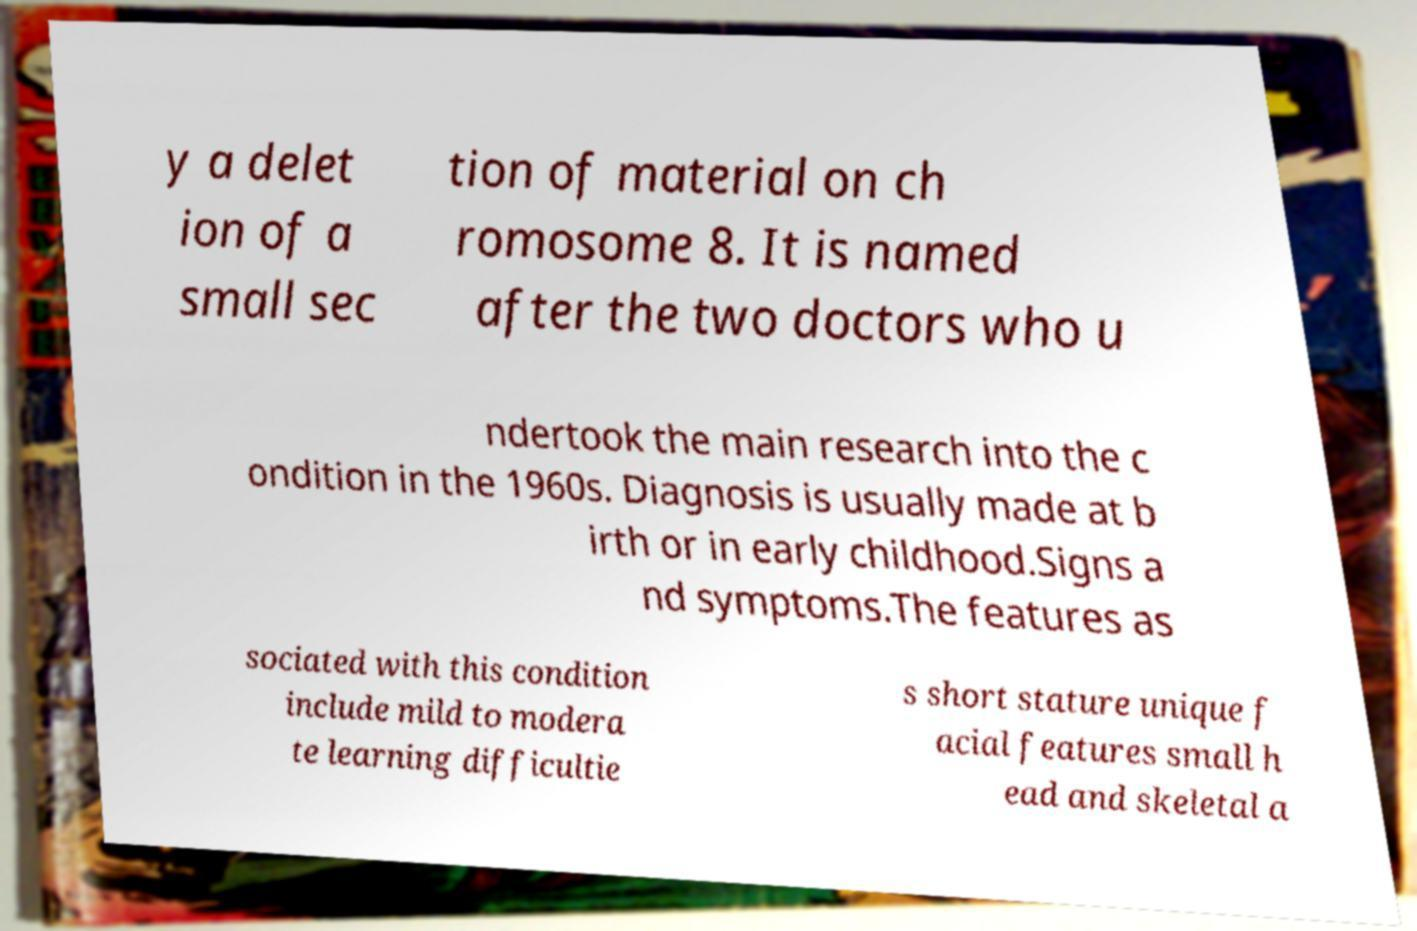For documentation purposes, I need the text within this image transcribed. Could you provide that? y a delet ion of a small sec tion of material on ch romosome 8. It is named after the two doctors who u ndertook the main research into the c ondition in the 1960s. Diagnosis is usually made at b irth or in early childhood.Signs a nd symptoms.The features as sociated with this condition include mild to modera te learning difficultie s short stature unique f acial features small h ead and skeletal a 